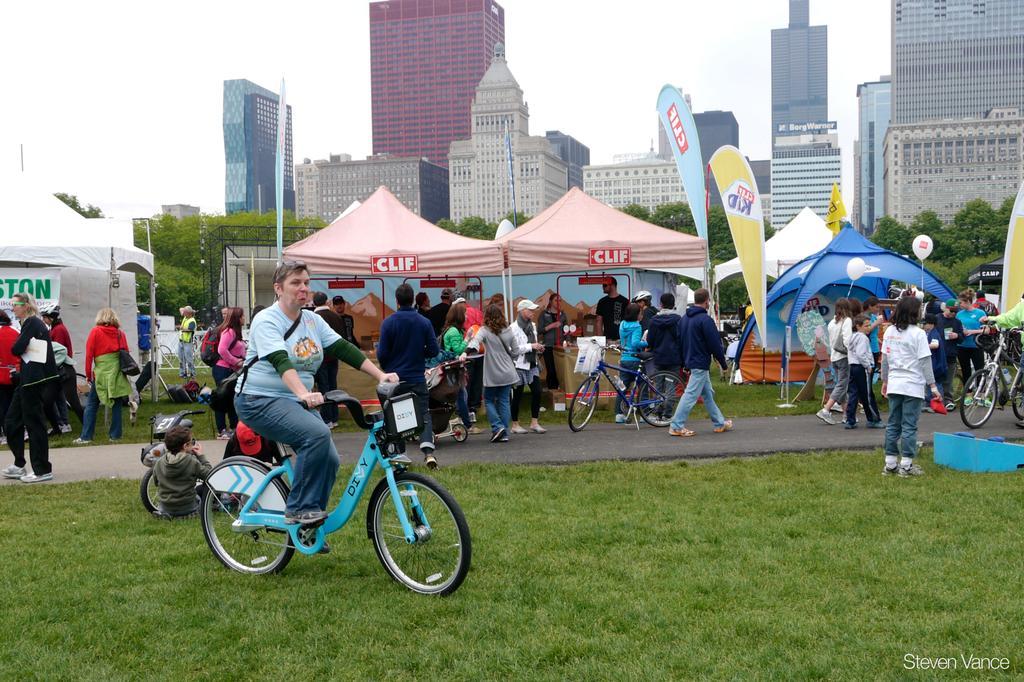Please provide a concise description of this image. In his image, we can see some persons, cycles and tents. There is a person wearing clothes and riding a bicycle on the grass. There are some buildings and trees in the middle of the image. There is a sky at the top of the image. 